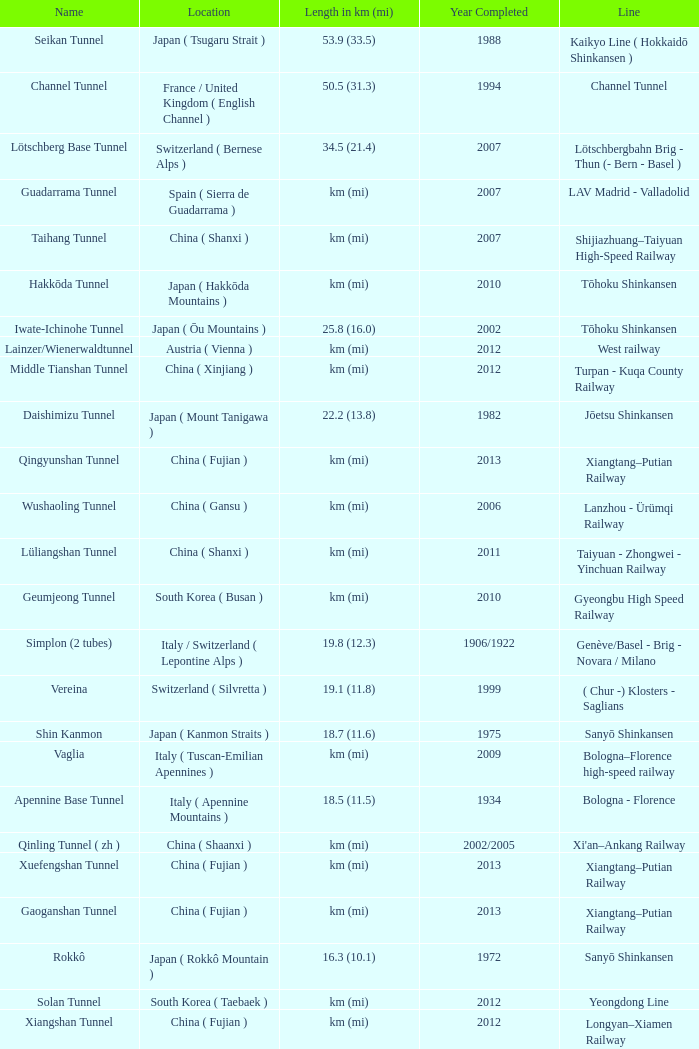In what year was the gardermobanen line construction finalized? 1999.0. 